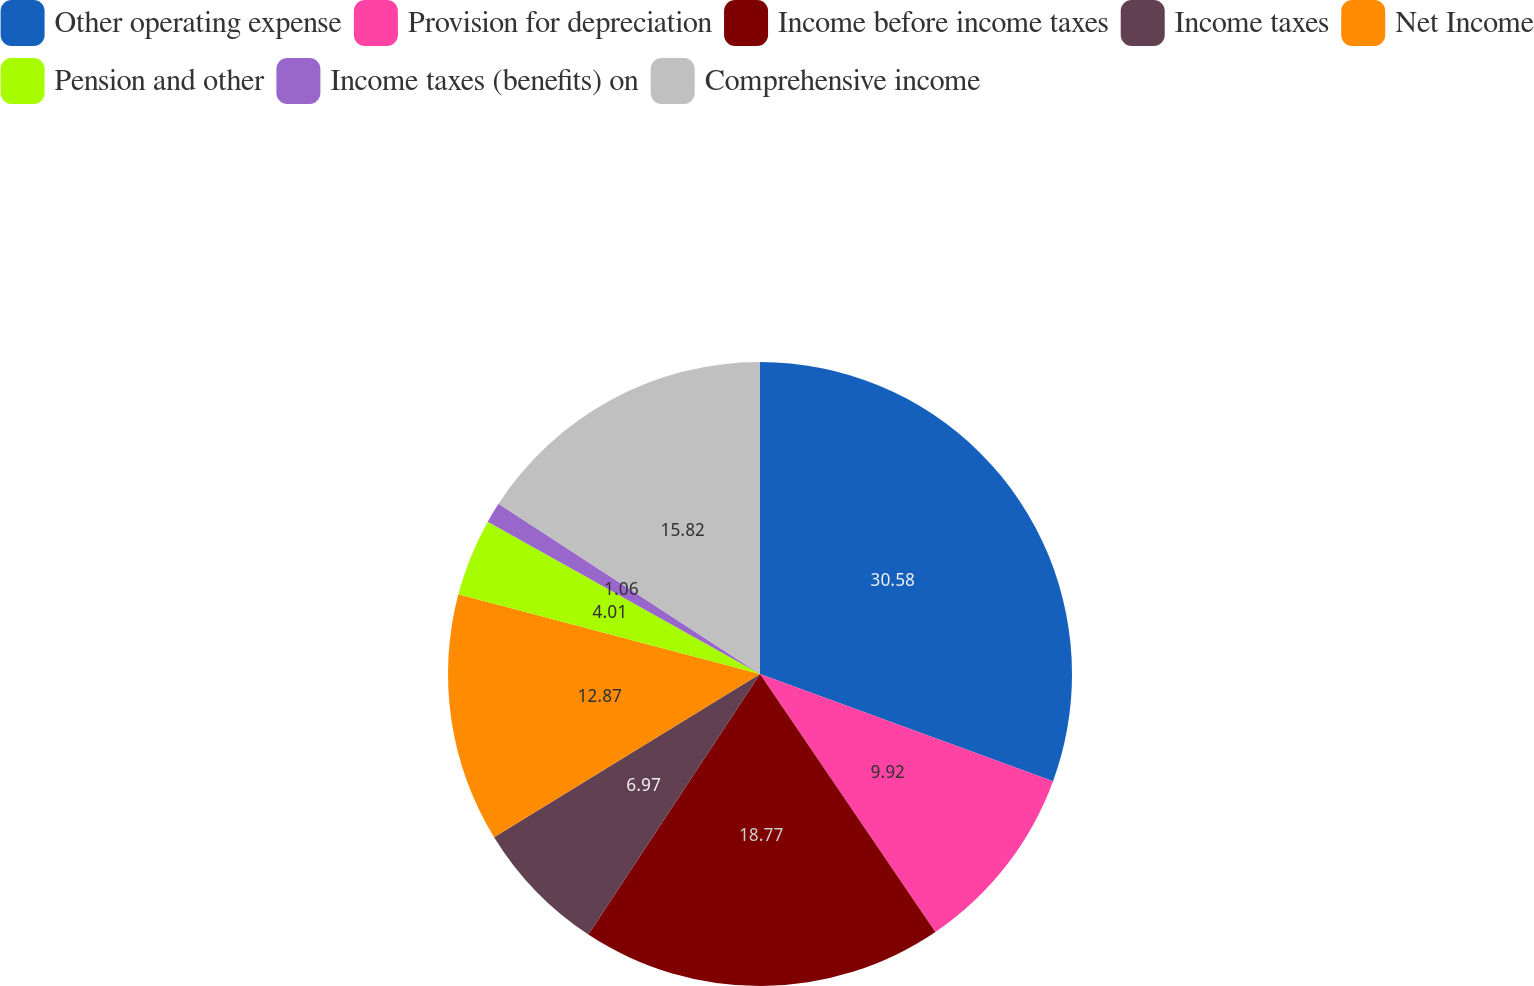Convert chart. <chart><loc_0><loc_0><loc_500><loc_500><pie_chart><fcel>Other operating expense<fcel>Provision for depreciation<fcel>Income before income taxes<fcel>Income taxes<fcel>Net Income<fcel>Pension and other<fcel>Income taxes (benefits) on<fcel>Comprehensive income<nl><fcel>30.58%<fcel>9.92%<fcel>18.77%<fcel>6.97%<fcel>12.87%<fcel>4.01%<fcel>1.06%<fcel>15.82%<nl></chart> 